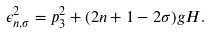Convert formula to latex. <formula><loc_0><loc_0><loc_500><loc_500>\epsilon ^ { 2 } _ { n , \sigma } = p ^ { 2 } _ { 3 } + ( 2 n + 1 - 2 \sigma ) g H .</formula> 